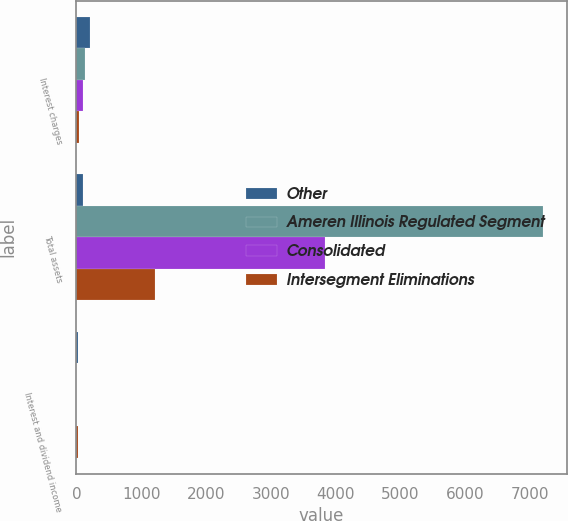<chart> <loc_0><loc_0><loc_500><loc_500><stacked_bar_chart><ecel><fcel>Interest charges<fcel>Total assets<fcel>Interest and dividend income<nl><fcel>Other<fcel>209<fcel>105<fcel>31<nl><fcel>Ameren Illinois Regulated Segment<fcel>136<fcel>7213<fcel>1<nl><fcel>Consolidated<fcel>105<fcel>3833<fcel>1<nl><fcel>Intersegment Eliminations<fcel>44<fcel>1211<fcel>25<nl></chart> 